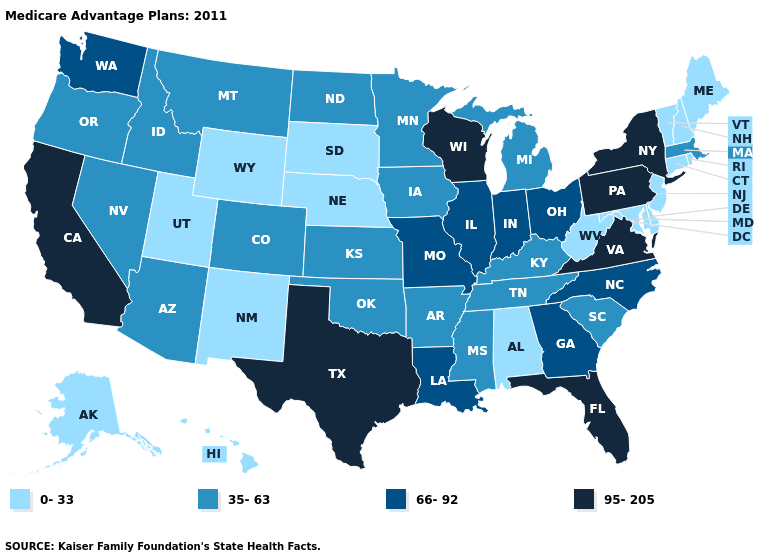Name the states that have a value in the range 0-33?
Be succinct. Alaska, Alabama, Connecticut, Delaware, Hawaii, Maryland, Maine, Nebraska, New Hampshire, New Jersey, New Mexico, Rhode Island, South Dakota, Utah, Vermont, West Virginia, Wyoming. Name the states that have a value in the range 35-63?
Concise answer only. Arkansas, Arizona, Colorado, Iowa, Idaho, Kansas, Kentucky, Massachusetts, Michigan, Minnesota, Mississippi, Montana, North Dakota, Nevada, Oklahoma, Oregon, South Carolina, Tennessee. Which states have the lowest value in the USA?
Be succinct. Alaska, Alabama, Connecticut, Delaware, Hawaii, Maryland, Maine, Nebraska, New Hampshire, New Jersey, New Mexico, Rhode Island, South Dakota, Utah, Vermont, West Virginia, Wyoming. Name the states that have a value in the range 95-205?
Answer briefly. California, Florida, New York, Pennsylvania, Texas, Virginia, Wisconsin. Does Florida have the highest value in the USA?
Give a very brief answer. Yes. Name the states that have a value in the range 0-33?
Write a very short answer. Alaska, Alabama, Connecticut, Delaware, Hawaii, Maryland, Maine, Nebraska, New Hampshire, New Jersey, New Mexico, Rhode Island, South Dakota, Utah, Vermont, West Virginia, Wyoming. What is the lowest value in the West?
Write a very short answer. 0-33. Among the states that border Nebraska , does Missouri have the highest value?
Short answer required. Yes. Which states have the lowest value in the South?
Quick response, please. Alabama, Delaware, Maryland, West Virginia. Does South Dakota have the same value as Maine?
Give a very brief answer. Yes. Does South Dakota have the highest value in the USA?
Be succinct. No. Among the states that border Oklahoma , does Texas have the highest value?
Give a very brief answer. Yes. Name the states that have a value in the range 0-33?
Be succinct. Alaska, Alabama, Connecticut, Delaware, Hawaii, Maryland, Maine, Nebraska, New Hampshire, New Jersey, New Mexico, Rhode Island, South Dakota, Utah, Vermont, West Virginia, Wyoming. How many symbols are there in the legend?
Keep it brief. 4. Among the states that border Pennsylvania , which have the lowest value?
Keep it brief. Delaware, Maryland, New Jersey, West Virginia. 